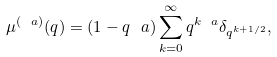Convert formula to latex. <formula><loc_0><loc_0><loc_500><loc_500>\mu ^ { ( \ a ) } ( q ) = ( 1 - q ^ { \ } a ) \sum _ { k = 0 } ^ { \infty } q ^ { k \ a } \delta _ { q ^ { k + 1 / 2 } } ,</formula> 